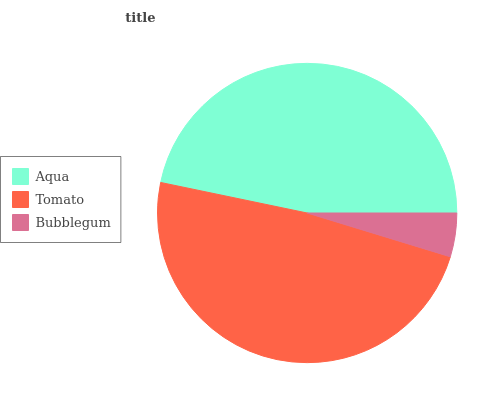Is Bubblegum the minimum?
Answer yes or no. Yes. Is Tomato the maximum?
Answer yes or no. Yes. Is Tomato the minimum?
Answer yes or no. No. Is Bubblegum the maximum?
Answer yes or no. No. Is Tomato greater than Bubblegum?
Answer yes or no. Yes. Is Bubblegum less than Tomato?
Answer yes or no. Yes. Is Bubblegum greater than Tomato?
Answer yes or no. No. Is Tomato less than Bubblegum?
Answer yes or no. No. Is Aqua the high median?
Answer yes or no. Yes. Is Aqua the low median?
Answer yes or no. Yes. Is Tomato the high median?
Answer yes or no. No. Is Tomato the low median?
Answer yes or no. No. 